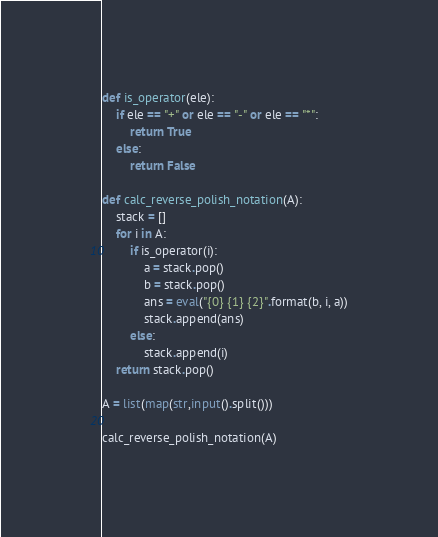<code> <loc_0><loc_0><loc_500><loc_500><_Python_>def is_operator(ele):
    if ele == "+" or ele == "-" or ele == "*":
        return True
    else:
        return False

def calc_reverse_polish_notation(A):
    stack = []
    for i in A:
        if is_operator(i):
            a = stack.pop()
            b = stack.pop()
            ans = eval("{0} {1} {2}".format(b, i, a))
            stack.append(ans)
        else:
            stack.append(i)
    return stack.pop()

A = list(map(str,input().split()))

calc_reverse_polish_notation(A)
</code> 